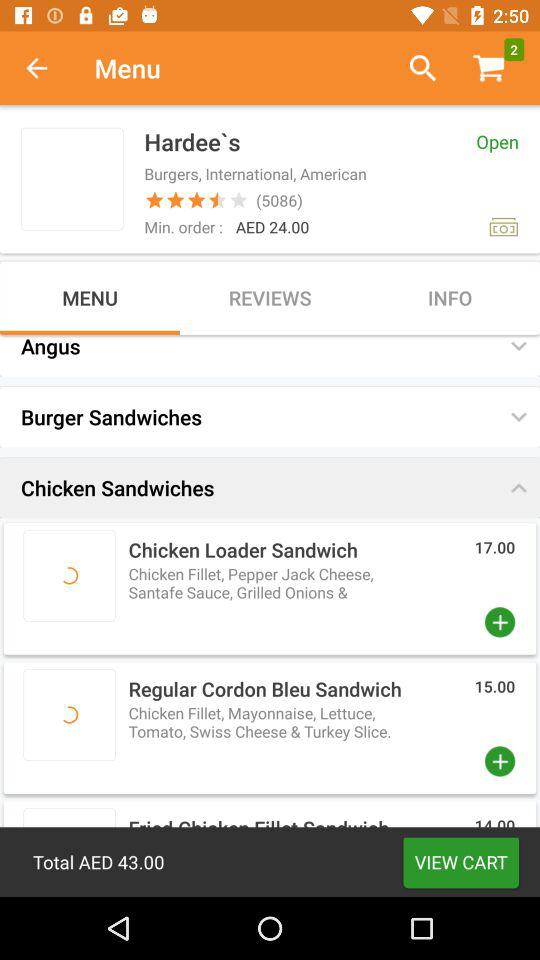What is the price of a "Chicken Loader Sandwich"? The price is AED 17. 